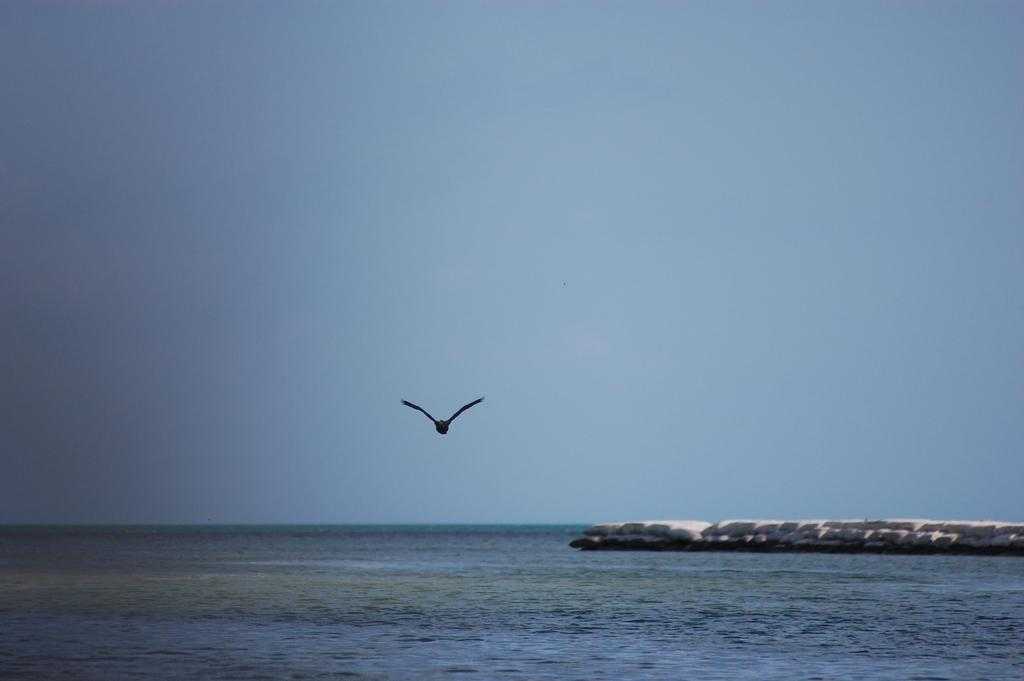What type of animal can be seen in the image? There is a bird in the image. What is the primary element in which the bird is situated? There is water visible in the image. What color is the sky in the background of the image? The sky is blue in the background of the image. How does the bird's growth rate compare to that of a human in the image? The image does not provide any information about the bird's growth rate or how it compares to a human's growth rate. What type of tail does the bird have in the image? There is no tail visible on the bird in the image. 